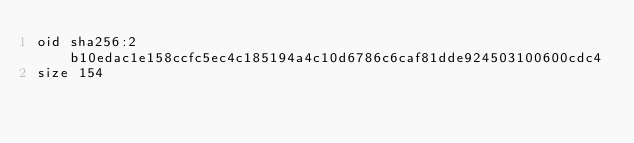Convert code to text. <code><loc_0><loc_0><loc_500><loc_500><_C#_>oid sha256:2b10edac1e158ccfc5ec4c185194a4c10d6786c6caf81dde924503100600cdc4
size 154
</code> 